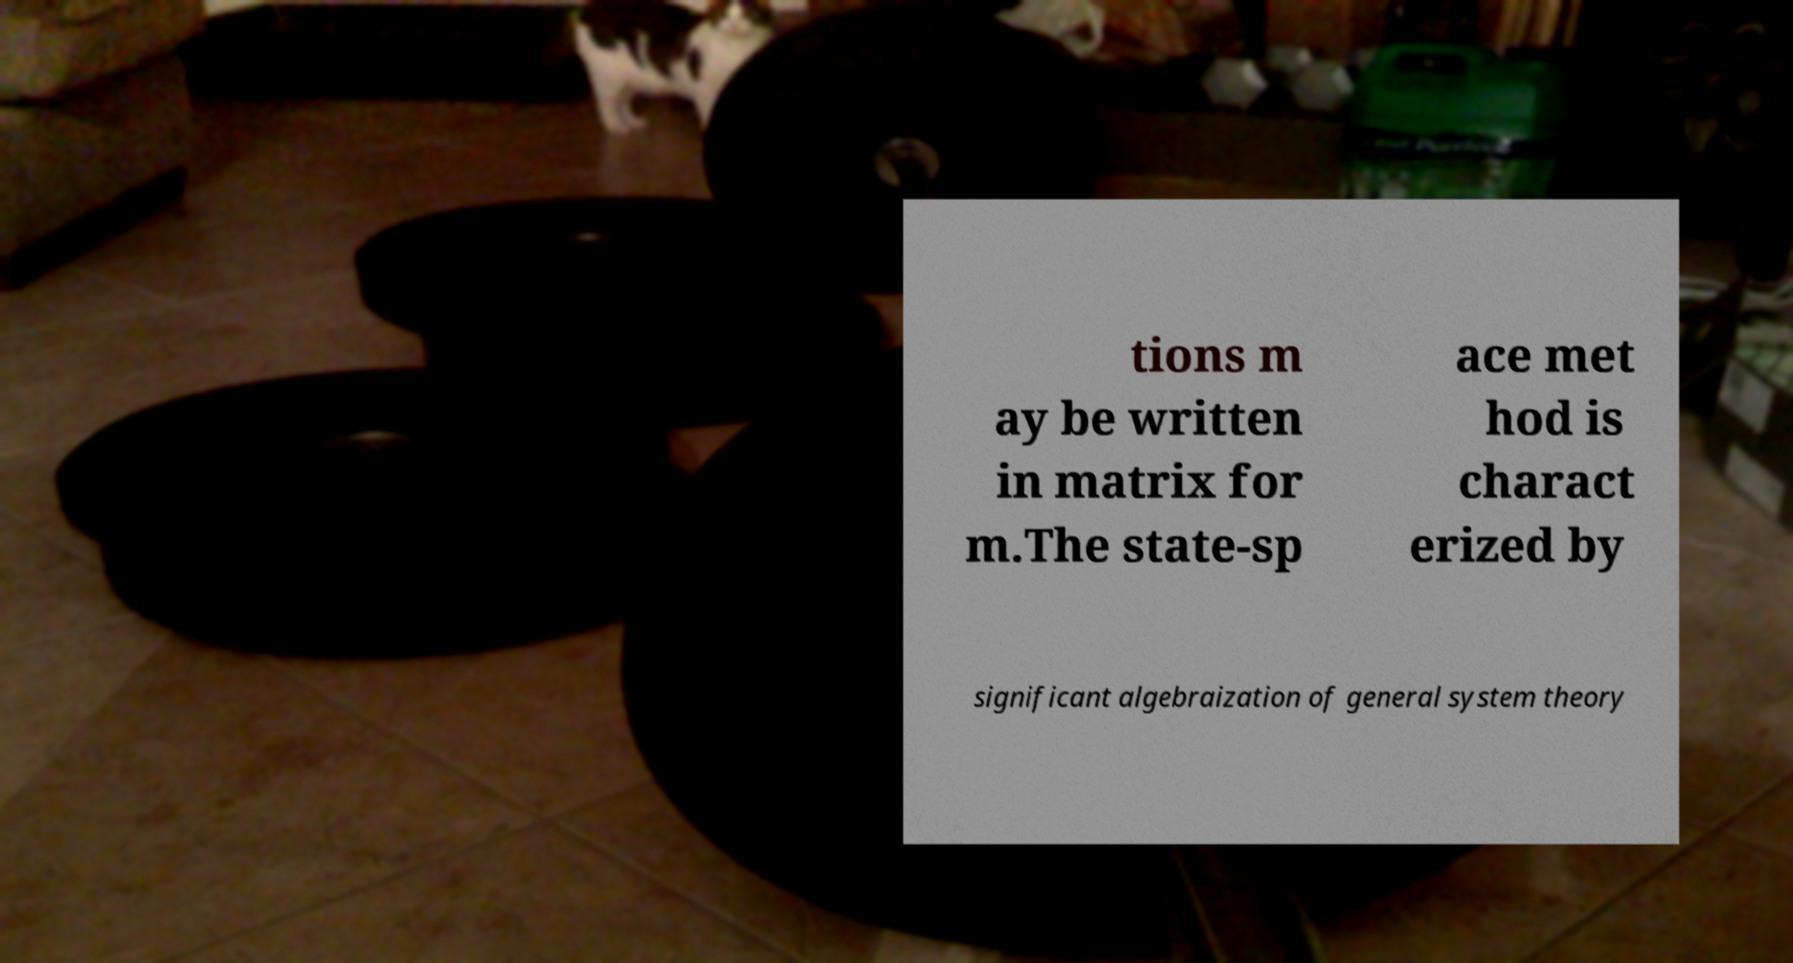There's text embedded in this image that I need extracted. Can you transcribe it verbatim? tions m ay be written in matrix for m.The state-sp ace met hod is charact erized by significant algebraization of general system theory 